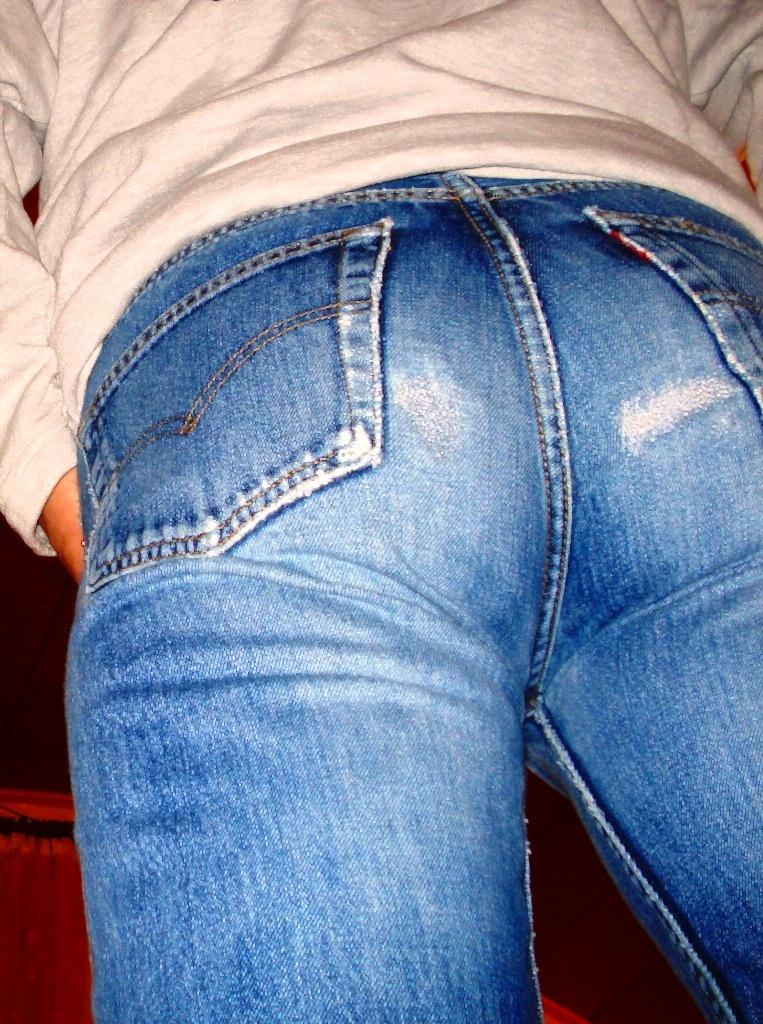What is present in the image? There is a person in the image. What type of clothing is the person wearing? The person is wearing a t-shirt and jeans. What type of tray is the person holding in the image? There is no tray present in the image; the person is not holding anything. 